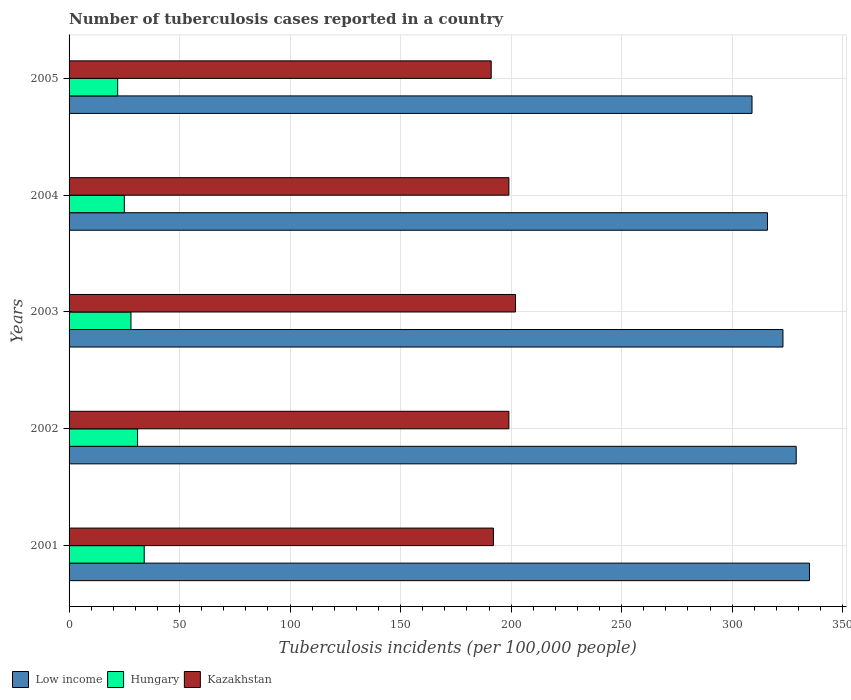Are the number of bars on each tick of the Y-axis equal?
Offer a terse response. Yes. How many bars are there on the 4th tick from the bottom?
Give a very brief answer. 3. What is the label of the 2nd group of bars from the top?
Your response must be concise. 2004. In how many cases, is the number of bars for a given year not equal to the number of legend labels?
Offer a terse response. 0. What is the number of tuberculosis cases reported in in Low income in 2004?
Give a very brief answer. 316. Across all years, what is the maximum number of tuberculosis cases reported in in Hungary?
Ensure brevity in your answer.  34. Across all years, what is the minimum number of tuberculosis cases reported in in Low income?
Your answer should be very brief. 309. In which year was the number of tuberculosis cases reported in in Low income maximum?
Ensure brevity in your answer.  2001. In which year was the number of tuberculosis cases reported in in Kazakhstan minimum?
Your response must be concise. 2005. What is the total number of tuberculosis cases reported in in Low income in the graph?
Make the answer very short. 1612. What is the difference between the number of tuberculosis cases reported in in Hungary in 2005 and the number of tuberculosis cases reported in in Low income in 2001?
Ensure brevity in your answer.  -313. What is the average number of tuberculosis cases reported in in Kazakhstan per year?
Make the answer very short. 196.6. In the year 2005, what is the difference between the number of tuberculosis cases reported in in Low income and number of tuberculosis cases reported in in Kazakhstan?
Ensure brevity in your answer.  118. What is the ratio of the number of tuberculosis cases reported in in Low income in 2002 to that in 2004?
Keep it short and to the point. 1.04. Is the number of tuberculosis cases reported in in Low income in 2003 less than that in 2004?
Make the answer very short. No. What is the difference between the highest and the lowest number of tuberculosis cases reported in in Kazakhstan?
Offer a terse response. 11. What does the 2nd bar from the top in 2004 represents?
Ensure brevity in your answer.  Hungary. What does the 3rd bar from the bottom in 2003 represents?
Your response must be concise. Kazakhstan. Is it the case that in every year, the sum of the number of tuberculosis cases reported in in Low income and number of tuberculosis cases reported in in Hungary is greater than the number of tuberculosis cases reported in in Kazakhstan?
Make the answer very short. Yes. How many years are there in the graph?
Make the answer very short. 5. Does the graph contain any zero values?
Provide a short and direct response. No. Where does the legend appear in the graph?
Provide a succinct answer. Bottom left. How are the legend labels stacked?
Ensure brevity in your answer.  Horizontal. What is the title of the graph?
Give a very brief answer. Number of tuberculosis cases reported in a country. What is the label or title of the X-axis?
Ensure brevity in your answer.  Tuberculosis incidents (per 100,0 people). What is the Tuberculosis incidents (per 100,000 people) of Low income in 2001?
Make the answer very short. 335. What is the Tuberculosis incidents (per 100,000 people) of Hungary in 2001?
Your answer should be very brief. 34. What is the Tuberculosis incidents (per 100,000 people) in Kazakhstan in 2001?
Your answer should be very brief. 192. What is the Tuberculosis incidents (per 100,000 people) in Low income in 2002?
Provide a succinct answer. 329. What is the Tuberculosis incidents (per 100,000 people) in Hungary in 2002?
Ensure brevity in your answer.  31. What is the Tuberculosis incidents (per 100,000 people) of Kazakhstan in 2002?
Give a very brief answer. 199. What is the Tuberculosis incidents (per 100,000 people) of Low income in 2003?
Ensure brevity in your answer.  323. What is the Tuberculosis incidents (per 100,000 people) of Kazakhstan in 2003?
Your response must be concise. 202. What is the Tuberculosis incidents (per 100,000 people) in Low income in 2004?
Your answer should be compact. 316. What is the Tuberculosis incidents (per 100,000 people) of Hungary in 2004?
Your response must be concise. 25. What is the Tuberculosis incidents (per 100,000 people) in Kazakhstan in 2004?
Offer a terse response. 199. What is the Tuberculosis incidents (per 100,000 people) in Low income in 2005?
Provide a short and direct response. 309. What is the Tuberculosis incidents (per 100,000 people) in Hungary in 2005?
Ensure brevity in your answer.  22. What is the Tuberculosis incidents (per 100,000 people) in Kazakhstan in 2005?
Give a very brief answer. 191. Across all years, what is the maximum Tuberculosis incidents (per 100,000 people) of Low income?
Make the answer very short. 335. Across all years, what is the maximum Tuberculosis incidents (per 100,000 people) in Hungary?
Your response must be concise. 34. Across all years, what is the maximum Tuberculosis incidents (per 100,000 people) in Kazakhstan?
Your answer should be compact. 202. Across all years, what is the minimum Tuberculosis incidents (per 100,000 people) in Low income?
Your response must be concise. 309. Across all years, what is the minimum Tuberculosis incidents (per 100,000 people) in Hungary?
Your response must be concise. 22. Across all years, what is the minimum Tuberculosis incidents (per 100,000 people) of Kazakhstan?
Make the answer very short. 191. What is the total Tuberculosis incidents (per 100,000 people) in Low income in the graph?
Keep it short and to the point. 1612. What is the total Tuberculosis incidents (per 100,000 people) in Hungary in the graph?
Ensure brevity in your answer.  140. What is the total Tuberculosis incidents (per 100,000 people) of Kazakhstan in the graph?
Offer a very short reply. 983. What is the difference between the Tuberculosis incidents (per 100,000 people) in Low income in 2001 and that in 2002?
Provide a short and direct response. 6. What is the difference between the Tuberculosis incidents (per 100,000 people) in Kazakhstan in 2001 and that in 2002?
Ensure brevity in your answer.  -7. What is the difference between the Tuberculosis incidents (per 100,000 people) of Kazakhstan in 2001 and that in 2003?
Offer a terse response. -10. What is the difference between the Tuberculosis incidents (per 100,000 people) of Low income in 2001 and that in 2004?
Give a very brief answer. 19. What is the difference between the Tuberculosis incidents (per 100,000 people) of Hungary in 2002 and that in 2003?
Offer a terse response. 3. What is the difference between the Tuberculosis incidents (per 100,000 people) of Kazakhstan in 2002 and that in 2003?
Offer a very short reply. -3. What is the difference between the Tuberculosis incidents (per 100,000 people) of Low income in 2002 and that in 2005?
Your answer should be very brief. 20. What is the difference between the Tuberculosis incidents (per 100,000 people) of Low income in 2003 and that in 2004?
Offer a terse response. 7. What is the difference between the Tuberculosis incidents (per 100,000 people) of Hungary in 2003 and that in 2004?
Make the answer very short. 3. What is the difference between the Tuberculosis incidents (per 100,000 people) of Low income in 2003 and that in 2005?
Your response must be concise. 14. What is the difference between the Tuberculosis incidents (per 100,000 people) of Hungary in 2003 and that in 2005?
Your answer should be very brief. 6. What is the difference between the Tuberculosis incidents (per 100,000 people) in Kazakhstan in 2003 and that in 2005?
Make the answer very short. 11. What is the difference between the Tuberculosis incidents (per 100,000 people) in Hungary in 2004 and that in 2005?
Make the answer very short. 3. What is the difference between the Tuberculosis incidents (per 100,000 people) in Kazakhstan in 2004 and that in 2005?
Ensure brevity in your answer.  8. What is the difference between the Tuberculosis incidents (per 100,000 people) of Low income in 2001 and the Tuberculosis incidents (per 100,000 people) of Hungary in 2002?
Ensure brevity in your answer.  304. What is the difference between the Tuberculosis incidents (per 100,000 people) of Low income in 2001 and the Tuberculosis incidents (per 100,000 people) of Kazakhstan in 2002?
Offer a terse response. 136. What is the difference between the Tuberculosis incidents (per 100,000 people) in Hungary in 2001 and the Tuberculosis incidents (per 100,000 people) in Kazakhstan in 2002?
Give a very brief answer. -165. What is the difference between the Tuberculosis incidents (per 100,000 people) in Low income in 2001 and the Tuberculosis incidents (per 100,000 people) in Hungary in 2003?
Keep it short and to the point. 307. What is the difference between the Tuberculosis incidents (per 100,000 people) in Low income in 2001 and the Tuberculosis incidents (per 100,000 people) in Kazakhstan in 2003?
Give a very brief answer. 133. What is the difference between the Tuberculosis incidents (per 100,000 people) of Hungary in 2001 and the Tuberculosis incidents (per 100,000 people) of Kazakhstan in 2003?
Your answer should be very brief. -168. What is the difference between the Tuberculosis incidents (per 100,000 people) in Low income in 2001 and the Tuberculosis incidents (per 100,000 people) in Hungary in 2004?
Your answer should be very brief. 310. What is the difference between the Tuberculosis incidents (per 100,000 people) in Low income in 2001 and the Tuberculosis incidents (per 100,000 people) in Kazakhstan in 2004?
Your answer should be very brief. 136. What is the difference between the Tuberculosis incidents (per 100,000 people) of Hungary in 2001 and the Tuberculosis incidents (per 100,000 people) of Kazakhstan in 2004?
Give a very brief answer. -165. What is the difference between the Tuberculosis incidents (per 100,000 people) in Low income in 2001 and the Tuberculosis incidents (per 100,000 people) in Hungary in 2005?
Your answer should be compact. 313. What is the difference between the Tuberculosis incidents (per 100,000 people) of Low income in 2001 and the Tuberculosis incidents (per 100,000 people) of Kazakhstan in 2005?
Provide a succinct answer. 144. What is the difference between the Tuberculosis incidents (per 100,000 people) in Hungary in 2001 and the Tuberculosis incidents (per 100,000 people) in Kazakhstan in 2005?
Your response must be concise. -157. What is the difference between the Tuberculosis incidents (per 100,000 people) of Low income in 2002 and the Tuberculosis incidents (per 100,000 people) of Hungary in 2003?
Your answer should be compact. 301. What is the difference between the Tuberculosis incidents (per 100,000 people) of Low income in 2002 and the Tuberculosis incidents (per 100,000 people) of Kazakhstan in 2003?
Make the answer very short. 127. What is the difference between the Tuberculosis incidents (per 100,000 people) of Hungary in 2002 and the Tuberculosis incidents (per 100,000 people) of Kazakhstan in 2003?
Provide a succinct answer. -171. What is the difference between the Tuberculosis incidents (per 100,000 people) in Low income in 2002 and the Tuberculosis incidents (per 100,000 people) in Hungary in 2004?
Give a very brief answer. 304. What is the difference between the Tuberculosis incidents (per 100,000 people) of Low income in 2002 and the Tuberculosis incidents (per 100,000 people) of Kazakhstan in 2004?
Provide a short and direct response. 130. What is the difference between the Tuberculosis incidents (per 100,000 people) in Hungary in 2002 and the Tuberculosis incidents (per 100,000 people) in Kazakhstan in 2004?
Ensure brevity in your answer.  -168. What is the difference between the Tuberculosis incidents (per 100,000 people) in Low income in 2002 and the Tuberculosis incidents (per 100,000 people) in Hungary in 2005?
Your response must be concise. 307. What is the difference between the Tuberculosis incidents (per 100,000 people) in Low income in 2002 and the Tuberculosis incidents (per 100,000 people) in Kazakhstan in 2005?
Your response must be concise. 138. What is the difference between the Tuberculosis incidents (per 100,000 people) of Hungary in 2002 and the Tuberculosis incidents (per 100,000 people) of Kazakhstan in 2005?
Keep it short and to the point. -160. What is the difference between the Tuberculosis incidents (per 100,000 people) in Low income in 2003 and the Tuberculosis incidents (per 100,000 people) in Hungary in 2004?
Your answer should be very brief. 298. What is the difference between the Tuberculosis incidents (per 100,000 people) of Low income in 2003 and the Tuberculosis incidents (per 100,000 people) of Kazakhstan in 2004?
Provide a short and direct response. 124. What is the difference between the Tuberculosis incidents (per 100,000 people) in Hungary in 2003 and the Tuberculosis incidents (per 100,000 people) in Kazakhstan in 2004?
Your answer should be compact. -171. What is the difference between the Tuberculosis incidents (per 100,000 people) of Low income in 2003 and the Tuberculosis incidents (per 100,000 people) of Hungary in 2005?
Provide a short and direct response. 301. What is the difference between the Tuberculosis incidents (per 100,000 people) of Low income in 2003 and the Tuberculosis incidents (per 100,000 people) of Kazakhstan in 2005?
Make the answer very short. 132. What is the difference between the Tuberculosis incidents (per 100,000 people) in Hungary in 2003 and the Tuberculosis incidents (per 100,000 people) in Kazakhstan in 2005?
Offer a terse response. -163. What is the difference between the Tuberculosis incidents (per 100,000 people) of Low income in 2004 and the Tuberculosis incidents (per 100,000 people) of Hungary in 2005?
Offer a terse response. 294. What is the difference between the Tuberculosis incidents (per 100,000 people) of Low income in 2004 and the Tuberculosis incidents (per 100,000 people) of Kazakhstan in 2005?
Your answer should be compact. 125. What is the difference between the Tuberculosis incidents (per 100,000 people) in Hungary in 2004 and the Tuberculosis incidents (per 100,000 people) in Kazakhstan in 2005?
Your answer should be compact. -166. What is the average Tuberculosis incidents (per 100,000 people) in Low income per year?
Keep it short and to the point. 322.4. What is the average Tuberculosis incidents (per 100,000 people) of Kazakhstan per year?
Keep it short and to the point. 196.6. In the year 2001, what is the difference between the Tuberculosis incidents (per 100,000 people) in Low income and Tuberculosis incidents (per 100,000 people) in Hungary?
Your response must be concise. 301. In the year 2001, what is the difference between the Tuberculosis incidents (per 100,000 people) of Low income and Tuberculosis incidents (per 100,000 people) of Kazakhstan?
Your answer should be compact. 143. In the year 2001, what is the difference between the Tuberculosis incidents (per 100,000 people) in Hungary and Tuberculosis incidents (per 100,000 people) in Kazakhstan?
Ensure brevity in your answer.  -158. In the year 2002, what is the difference between the Tuberculosis incidents (per 100,000 people) of Low income and Tuberculosis incidents (per 100,000 people) of Hungary?
Make the answer very short. 298. In the year 2002, what is the difference between the Tuberculosis incidents (per 100,000 people) in Low income and Tuberculosis incidents (per 100,000 people) in Kazakhstan?
Give a very brief answer. 130. In the year 2002, what is the difference between the Tuberculosis incidents (per 100,000 people) of Hungary and Tuberculosis incidents (per 100,000 people) of Kazakhstan?
Your response must be concise. -168. In the year 2003, what is the difference between the Tuberculosis incidents (per 100,000 people) of Low income and Tuberculosis incidents (per 100,000 people) of Hungary?
Your response must be concise. 295. In the year 2003, what is the difference between the Tuberculosis incidents (per 100,000 people) in Low income and Tuberculosis incidents (per 100,000 people) in Kazakhstan?
Your response must be concise. 121. In the year 2003, what is the difference between the Tuberculosis incidents (per 100,000 people) of Hungary and Tuberculosis incidents (per 100,000 people) of Kazakhstan?
Offer a very short reply. -174. In the year 2004, what is the difference between the Tuberculosis incidents (per 100,000 people) of Low income and Tuberculosis incidents (per 100,000 people) of Hungary?
Offer a terse response. 291. In the year 2004, what is the difference between the Tuberculosis incidents (per 100,000 people) of Low income and Tuberculosis incidents (per 100,000 people) of Kazakhstan?
Your answer should be very brief. 117. In the year 2004, what is the difference between the Tuberculosis incidents (per 100,000 people) of Hungary and Tuberculosis incidents (per 100,000 people) of Kazakhstan?
Keep it short and to the point. -174. In the year 2005, what is the difference between the Tuberculosis incidents (per 100,000 people) in Low income and Tuberculosis incidents (per 100,000 people) in Hungary?
Your answer should be very brief. 287. In the year 2005, what is the difference between the Tuberculosis incidents (per 100,000 people) in Low income and Tuberculosis incidents (per 100,000 people) in Kazakhstan?
Offer a very short reply. 118. In the year 2005, what is the difference between the Tuberculosis incidents (per 100,000 people) in Hungary and Tuberculosis incidents (per 100,000 people) in Kazakhstan?
Offer a very short reply. -169. What is the ratio of the Tuberculosis incidents (per 100,000 people) in Low income in 2001 to that in 2002?
Offer a very short reply. 1.02. What is the ratio of the Tuberculosis incidents (per 100,000 people) in Hungary in 2001 to that in 2002?
Your response must be concise. 1.1. What is the ratio of the Tuberculosis incidents (per 100,000 people) of Kazakhstan in 2001 to that in 2002?
Provide a succinct answer. 0.96. What is the ratio of the Tuberculosis incidents (per 100,000 people) in Low income in 2001 to that in 2003?
Keep it short and to the point. 1.04. What is the ratio of the Tuberculosis incidents (per 100,000 people) in Hungary in 2001 to that in 2003?
Your answer should be very brief. 1.21. What is the ratio of the Tuberculosis incidents (per 100,000 people) in Kazakhstan in 2001 to that in 2003?
Your answer should be compact. 0.95. What is the ratio of the Tuberculosis incidents (per 100,000 people) of Low income in 2001 to that in 2004?
Your response must be concise. 1.06. What is the ratio of the Tuberculosis incidents (per 100,000 people) of Hungary in 2001 to that in 2004?
Your answer should be very brief. 1.36. What is the ratio of the Tuberculosis incidents (per 100,000 people) in Kazakhstan in 2001 to that in 2004?
Make the answer very short. 0.96. What is the ratio of the Tuberculosis incidents (per 100,000 people) of Low income in 2001 to that in 2005?
Your answer should be very brief. 1.08. What is the ratio of the Tuberculosis incidents (per 100,000 people) in Hungary in 2001 to that in 2005?
Give a very brief answer. 1.55. What is the ratio of the Tuberculosis incidents (per 100,000 people) in Low income in 2002 to that in 2003?
Ensure brevity in your answer.  1.02. What is the ratio of the Tuberculosis incidents (per 100,000 people) of Hungary in 2002 to that in 2003?
Provide a short and direct response. 1.11. What is the ratio of the Tuberculosis incidents (per 100,000 people) of Kazakhstan in 2002 to that in 2003?
Ensure brevity in your answer.  0.99. What is the ratio of the Tuberculosis incidents (per 100,000 people) in Low income in 2002 to that in 2004?
Your answer should be compact. 1.04. What is the ratio of the Tuberculosis incidents (per 100,000 people) in Hungary in 2002 to that in 2004?
Your answer should be compact. 1.24. What is the ratio of the Tuberculosis incidents (per 100,000 people) in Low income in 2002 to that in 2005?
Your answer should be very brief. 1.06. What is the ratio of the Tuberculosis incidents (per 100,000 people) of Hungary in 2002 to that in 2005?
Give a very brief answer. 1.41. What is the ratio of the Tuberculosis incidents (per 100,000 people) of Kazakhstan in 2002 to that in 2005?
Your response must be concise. 1.04. What is the ratio of the Tuberculosis incidents (per 100,000 people) in Low income in 2003 to that in 2004?
Provide a short and direct response. 1.02. What is the ratio of the Tuberculosis incidents (per 100,000 people) in Hungary in 2003 to that in 2004?
Offer a very short reply. 1.12. What is the ratio of the Tuberculosis incidents (per 100,000 people) in Kazakhstan in 2003 to that in 2004?
Make the answer very short. 1.02. What is the ratio of the Tuberculosis incidents (per 100,000 people) of Low income in 2003 to that in 2005?
Offer a very short reply. 1.05. What is the ratio of the Tuberculosis incidents (per 100,000 people) of Hungary in 2003 to that in 2005?
Keep it short and to the point. 1.27. What is the ratio of the Tuberculosis incidents (per 100,000 people) of Kazakhstan in 2003 to that in 2005?
Make the answer very short. 1.06. What is the ratio of the Tuberculosis incidents (per 100,000 people) of Low income in 2004 to that in 2005?
Keep it short and to the point. 1.02. What is the ratio of the Tuberculosis incidents (per 100,000 people) in Hungary in 2004 to that in 2005?
Make the answer very short. 1.14. What is the ratio of the Tuberculosis incidents (per 100,000 people) in Kazakhstan in 2004 to that in 2005?
Make the answer very short. 1.04. What is the difference between the highest and the second highest Tuberculosis incidents (per 100,000 people) in Low income?
Ensure brevity in your answer.  6. What is the difference between the highest and the second highest Tuberculosis incidents (per 100,000 people) in Hungary?
Provide a succinct answer. 3. What is the difference between the highest and the lowest Tuberculosis incidents (per 100,000 people) of Low income?
Your response must be concise. 26. What is the difference between the highest and the lowest Tuberculosis incidents (per 100,000 people) in Hungary?
Your answer should be compact. 12. 